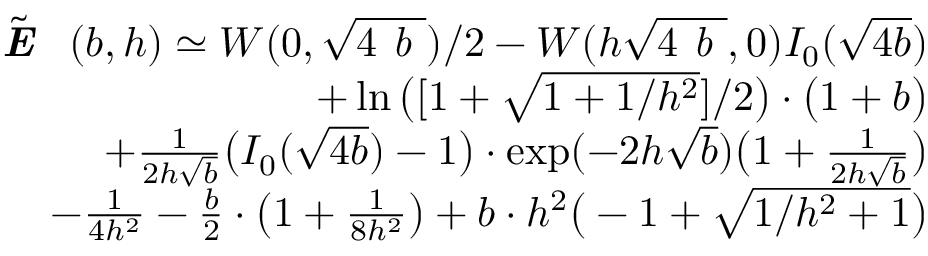<formula> <loc_0><loc_0><loc_500><loc_500>\begin{array} { r l r } & { \tilde { \emph { E } } ( b , h ) \simeq W ( 0 , \sqrt { 4 \emph { b } } ) / 2 - W ( h \sqrt { 4 \emph { b } } , 0 ) I _ { 0 } ( \sqrt { 4 b } ) } \\ & { + \ln \left ( [ 1 + \sqrt { 1 + 1 / h ^ { 2 } } ] / 2 \right ) \cdot \left ( 1 + b \right ) } \\ & { + { \frac { 1 } { 2 h \sqrt { b } } } \left ( I _ { 0 } ( \sqrt { 4 b } ) - 1 \right ) \cdot \exp ( - 2 h \sqrt { b } ) \left ( 1 + { \frac { 1 } { 2 h \sqrt { b } } } \right ) } \\ & { - { \frac { 1 } { 4 h ^ { 2 } } } - { \frac { b } { 2 } } \cdot \left ( 1 + { \frac { 1 } { 8 h ^ { 2 } } } \right ) + b \cdot h ^ { 2 } \left ( - 1 + \sqrt { 1 / h ^ { 2 } + 1 } \right ) } \end{array}</formula> 